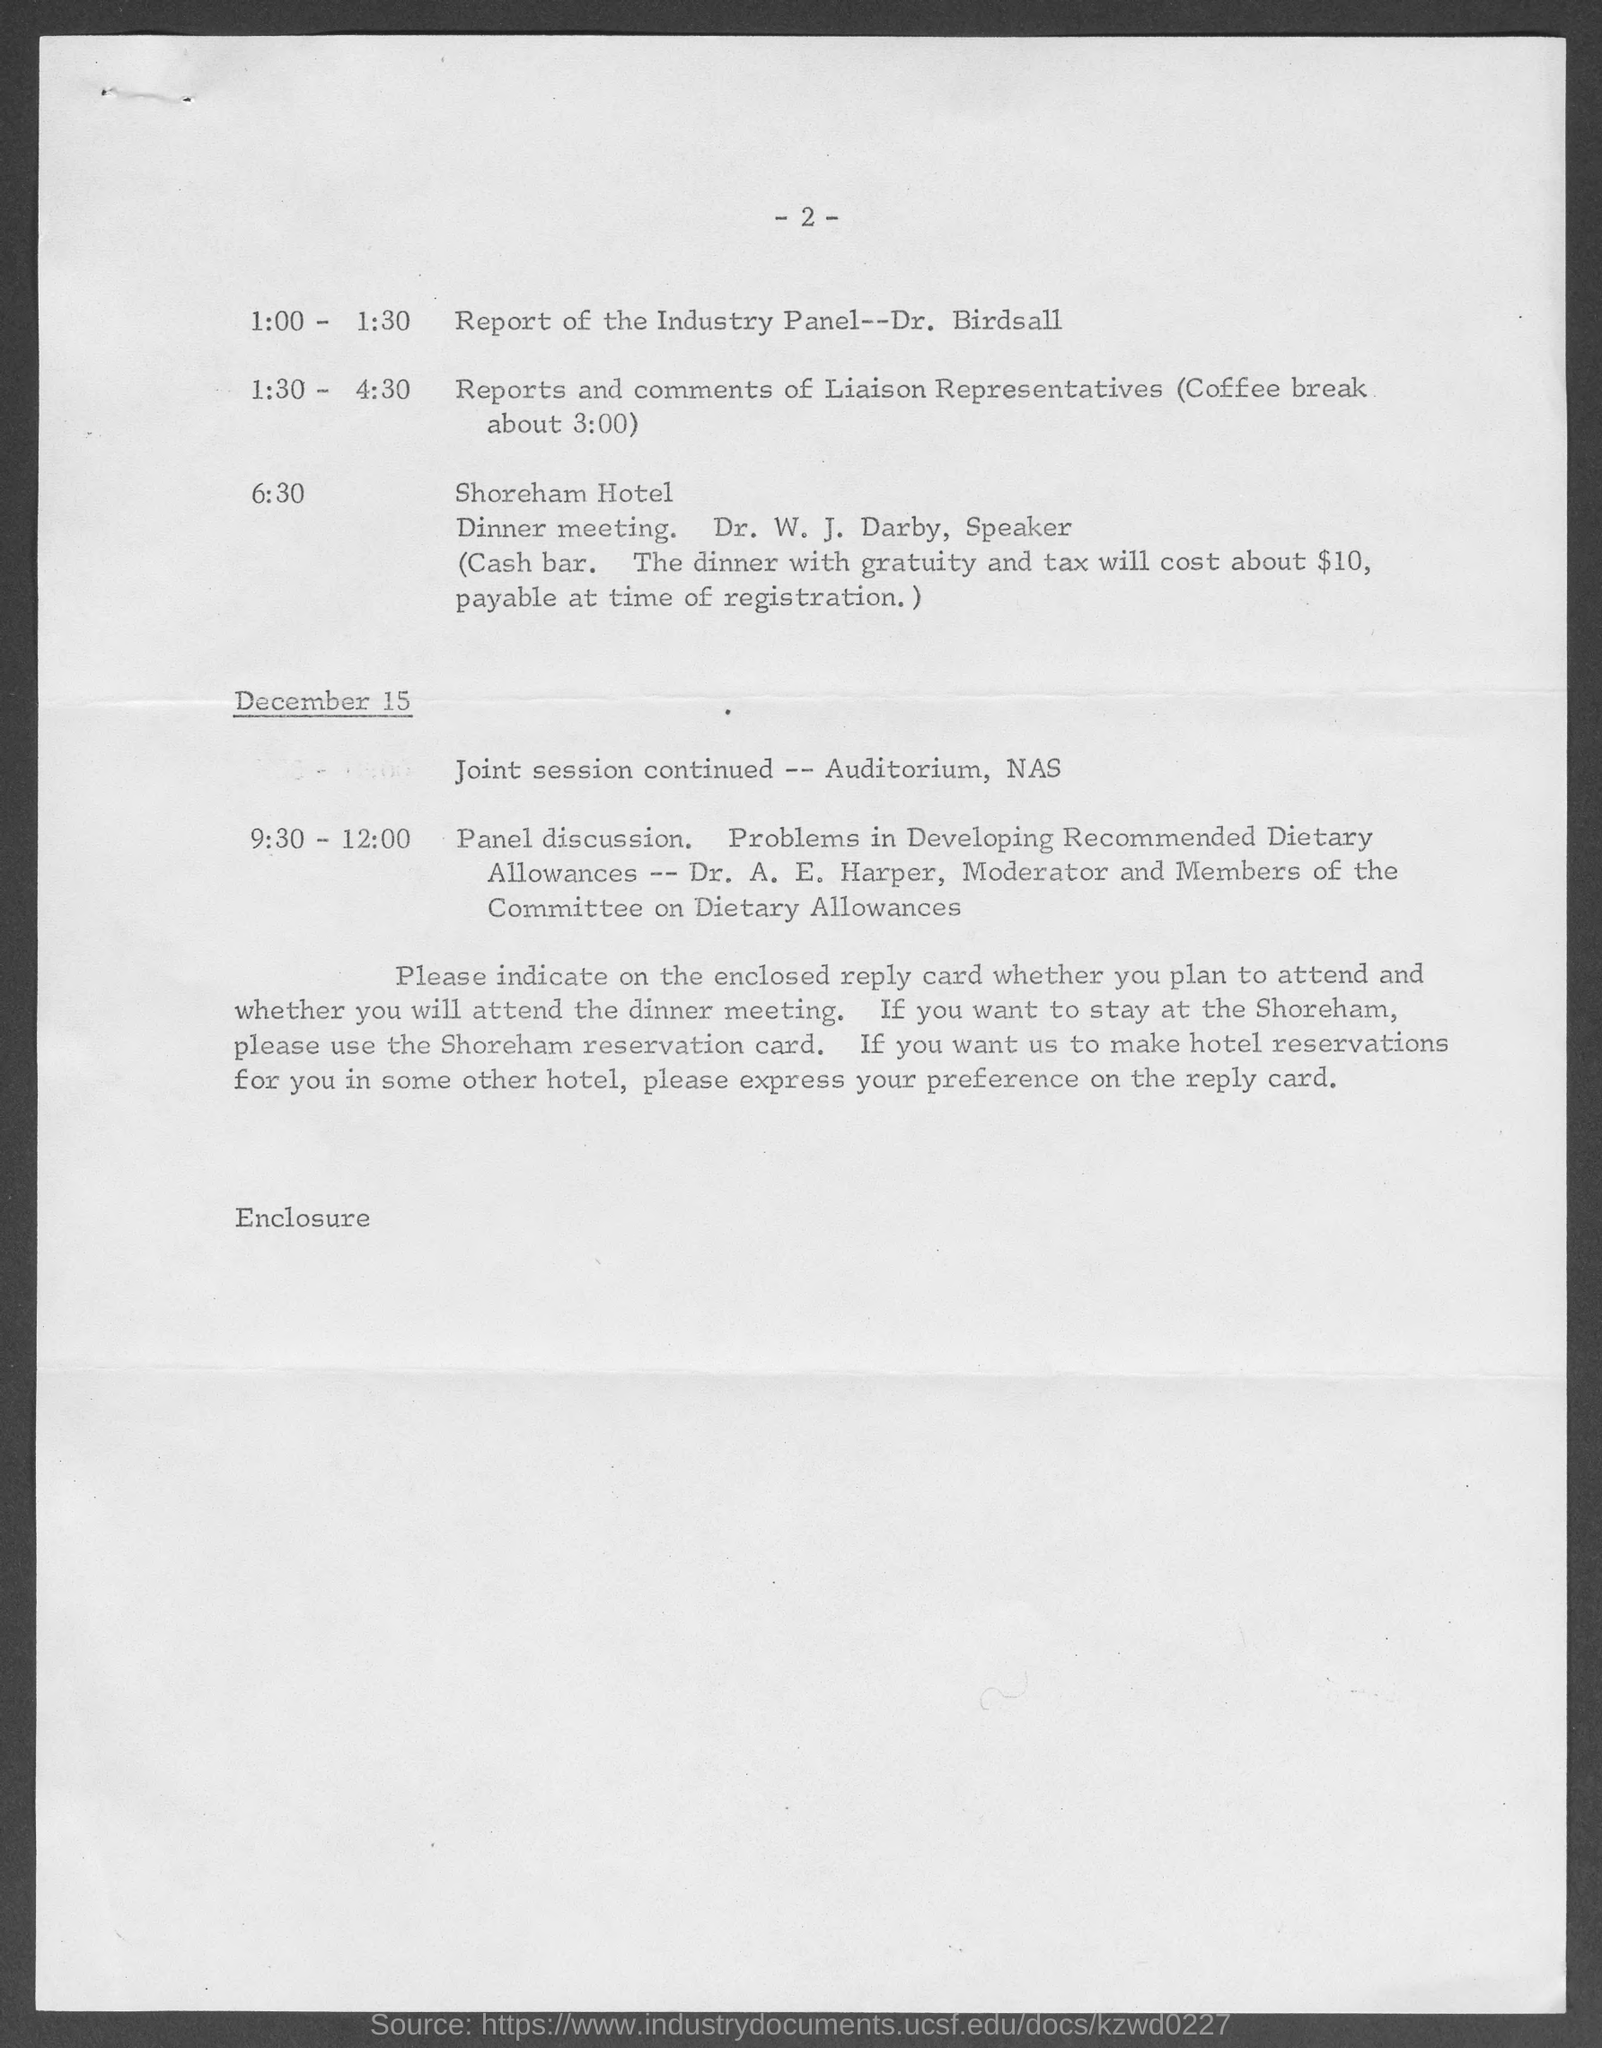Mention a couple of crucial points in this snapshot. The name of the hotel is the Shoreham Hotel. The page number is 2, as declared. The date mentioned in the document is December 15. 